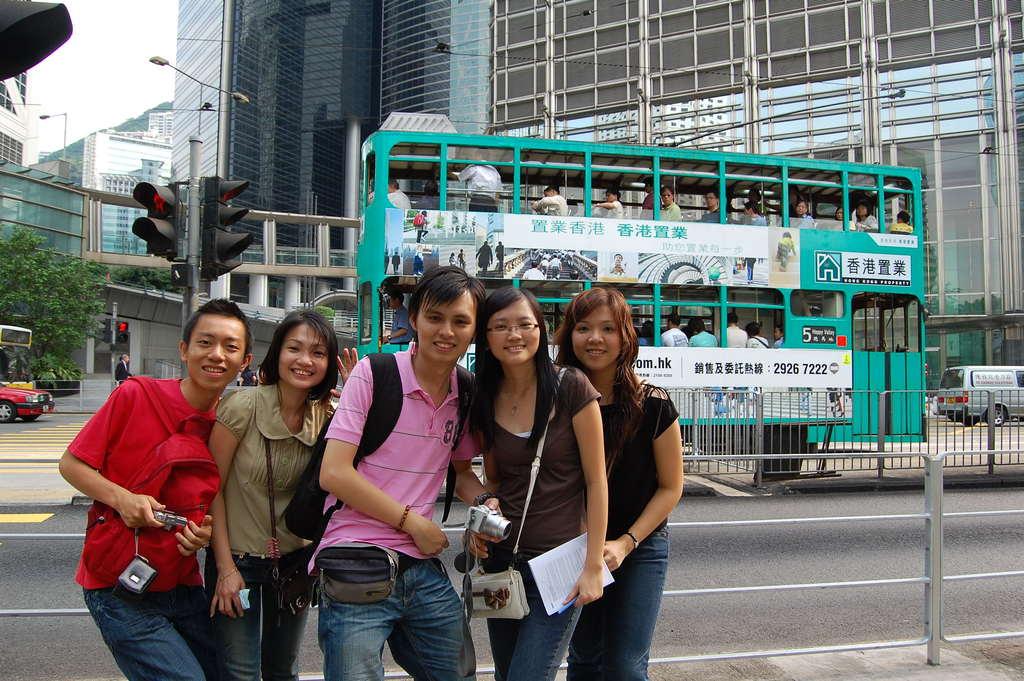What's the phone number on the bus?
Offer a terse response. 29267222. What is the visible number on the pink shirt?
Your response must be concise. 8. 